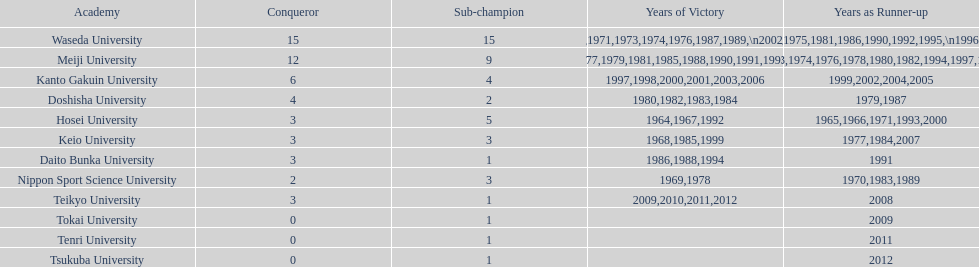Which universities had a number of wins higher than 12? Waseda University. 